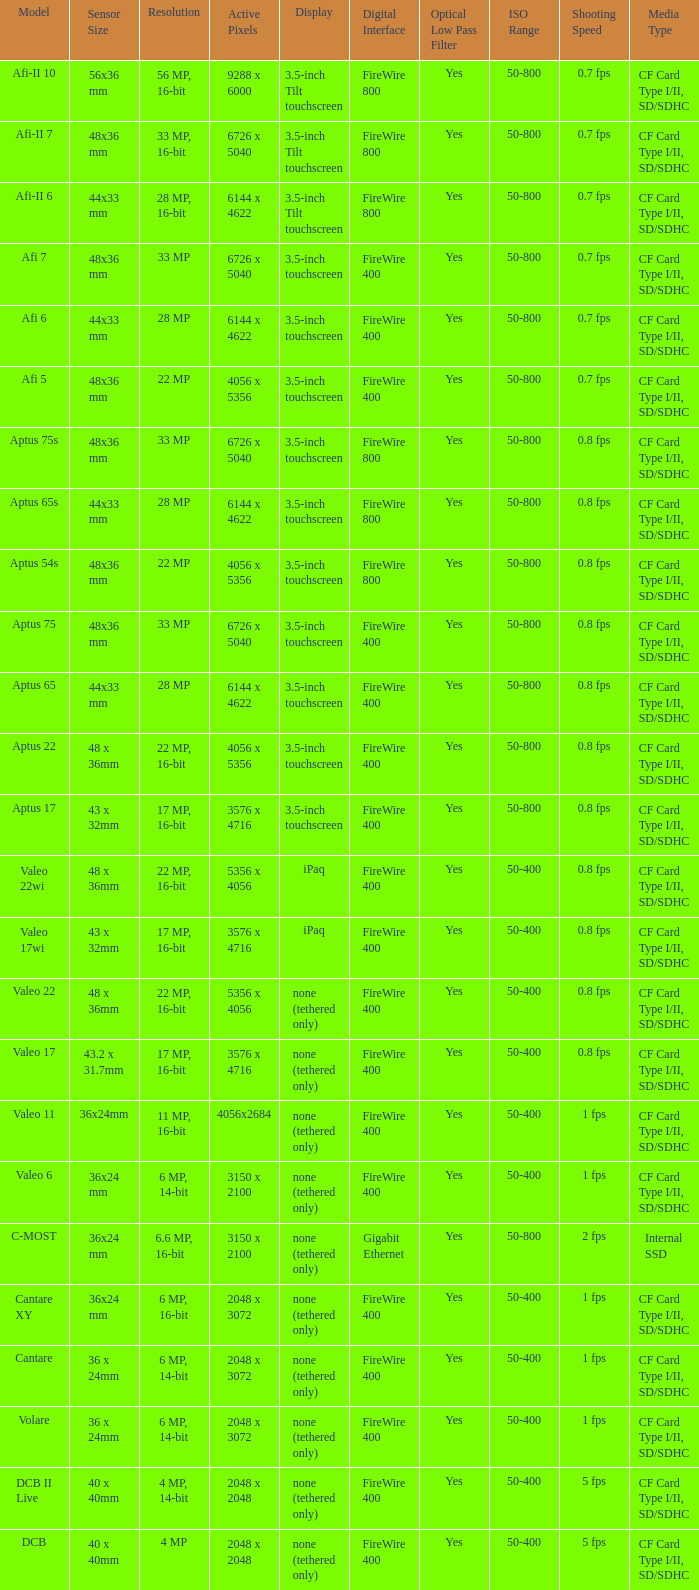What are the active pixels of the c-most model camera? 3150 x 2100. 